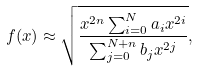<formula> <loc_0><loc_0><loc_500><loc_500>f ( x ) \approx \sqrt { \frac { x ^ { 2 n } \sum _ { i = 0 } ^ { N } a _ { i } x ^ { 2 i } } { \sum _ { j = 0 } ^ { N + n } b _ { j } x ^ { 2 j } } } ,</formula> 